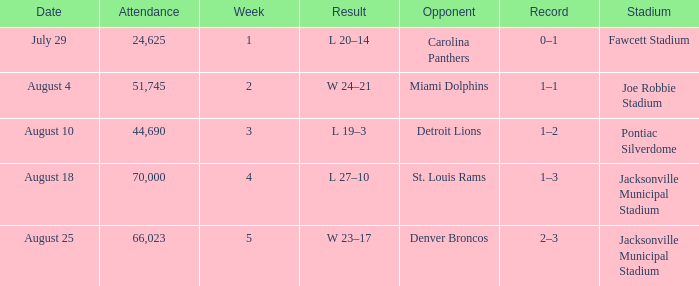What is the Record in Week 2? 1–1. 